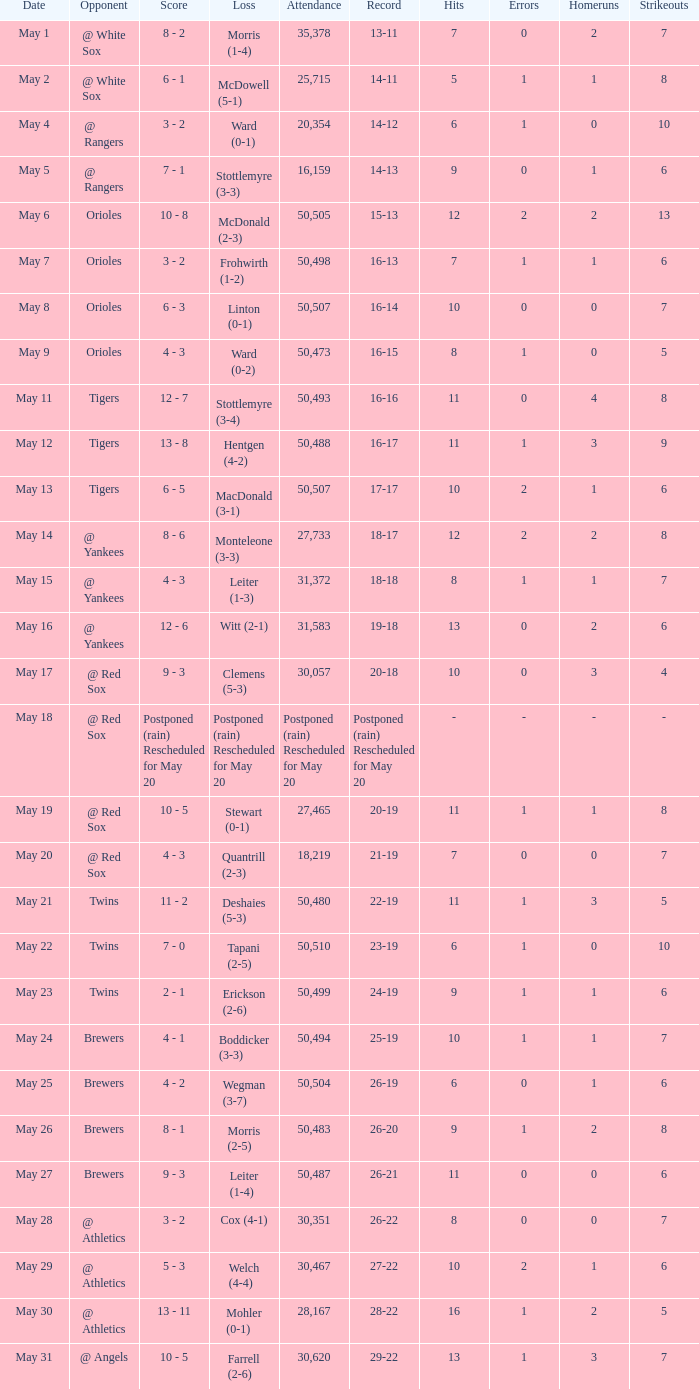On may 29, which team faced a defeat? Welch (4-4). 